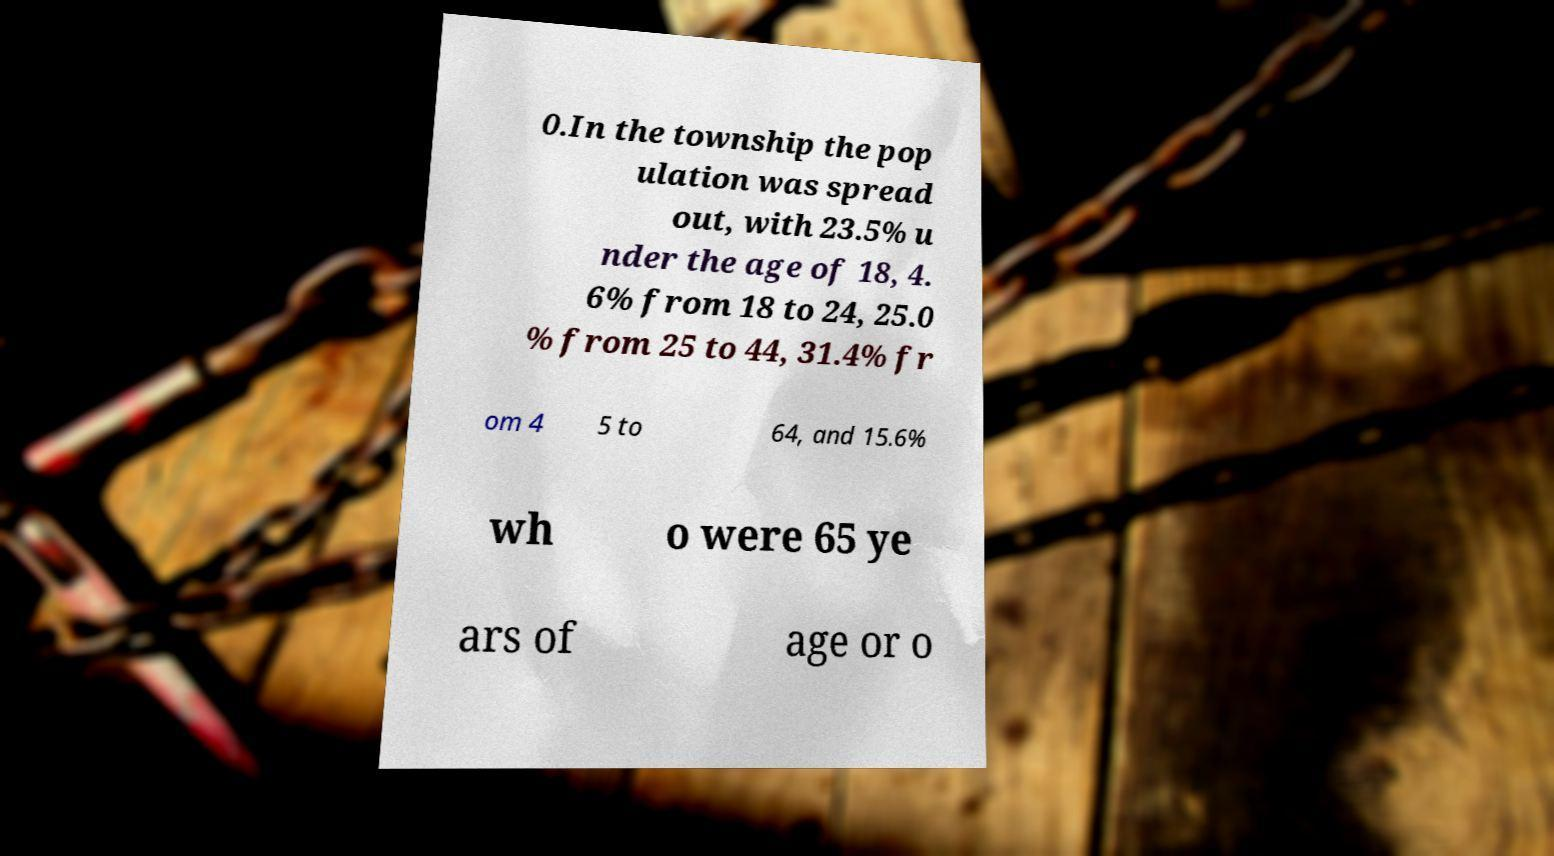Could you extract and type out the text from this image? 0.In the township the pop ulation was spread out, with 23.5% u nder the age of 18, 4. 6% from 18 to 24, 25.0 % from 25 to 44, 31.4% fr om 4 5 to 64, and 15.6% wh o were 65 ye ars of age or o 